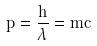Convert formula to latex. <formula><loc_0><loc_0><loc_500><loc_500>p = \frac { h } { \lambda } = m c</formula> 